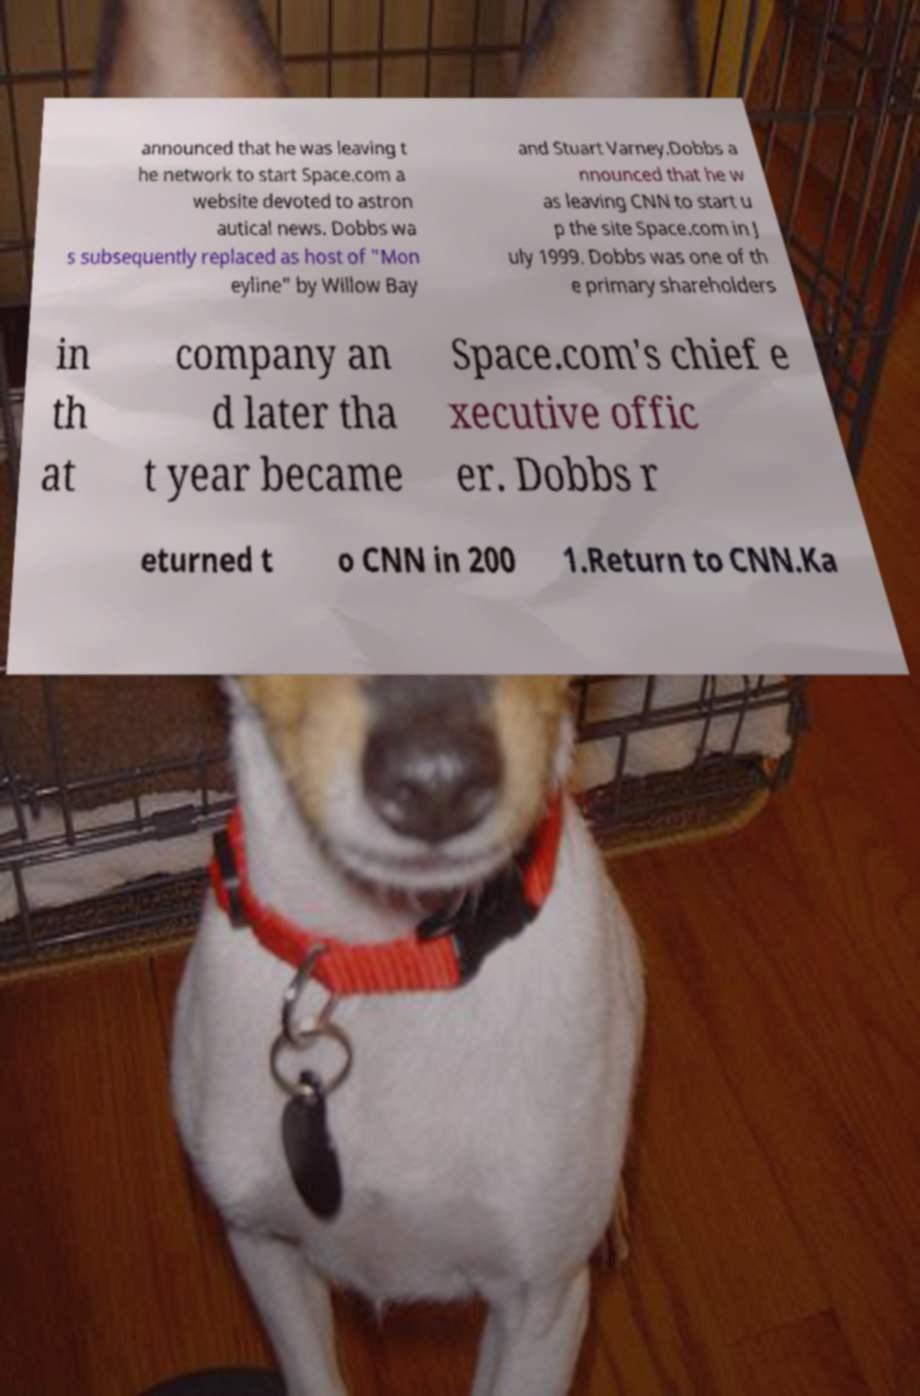For documentation purposes, I need the text within this image transcribed. Could you provide that? announced that he was leaving t he network to start Space.com a website devoted to astron autical news. Dobbs wa s subsequently replaced as host of "Mon eyline" by Willow Bay and Stuart Varney.Dobbs a nnounced that he w as leaving CNN to start u p the site Space.com in J uly 1999. Dobbs was one of th e primary shareholders in th at company an d later tha t year became Space.com's chief e xecutive offic er. Dobbs r eturned t o CNN in 200 1.Return to CNN.Ka 